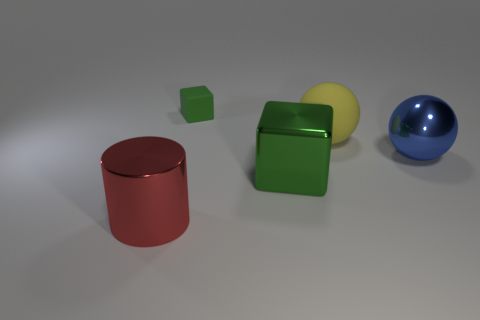Add 4 red shiny things. How many objects exist? 9 Subtract all blocks. How many objects are left? 3 Subtract 0 green cylinders. How many objects are left? 5 Subtract all big shiny things. Subtract all small yellow balls. How many objects are left? 2 Add 2 rubber balls. How many rubber balls are left? 3 Add 3 red balls. How many red balls exist? 3 